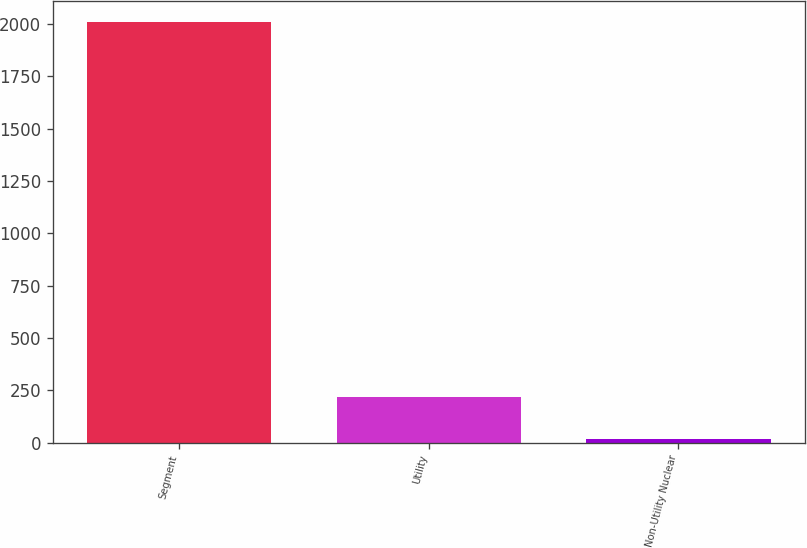Convert chart. <chart><loc_0><loc_0><loc_500><loc_500><bar_chart><fcel>Segment<fcel>Utility<fcel>Non-Utility Nuclear<nl><fcel>2008<fcel>217.9<fcel>19<nl></chart> 